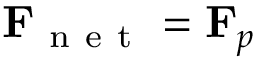Convert formula to latex. <formula><loc_0><loc_0><loc_500><loc_500>F _ { n e t } = F _ { p }</formula> 